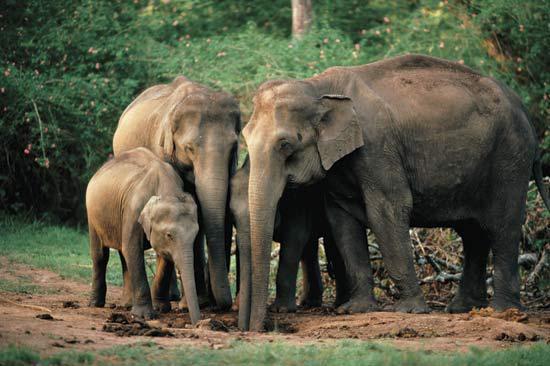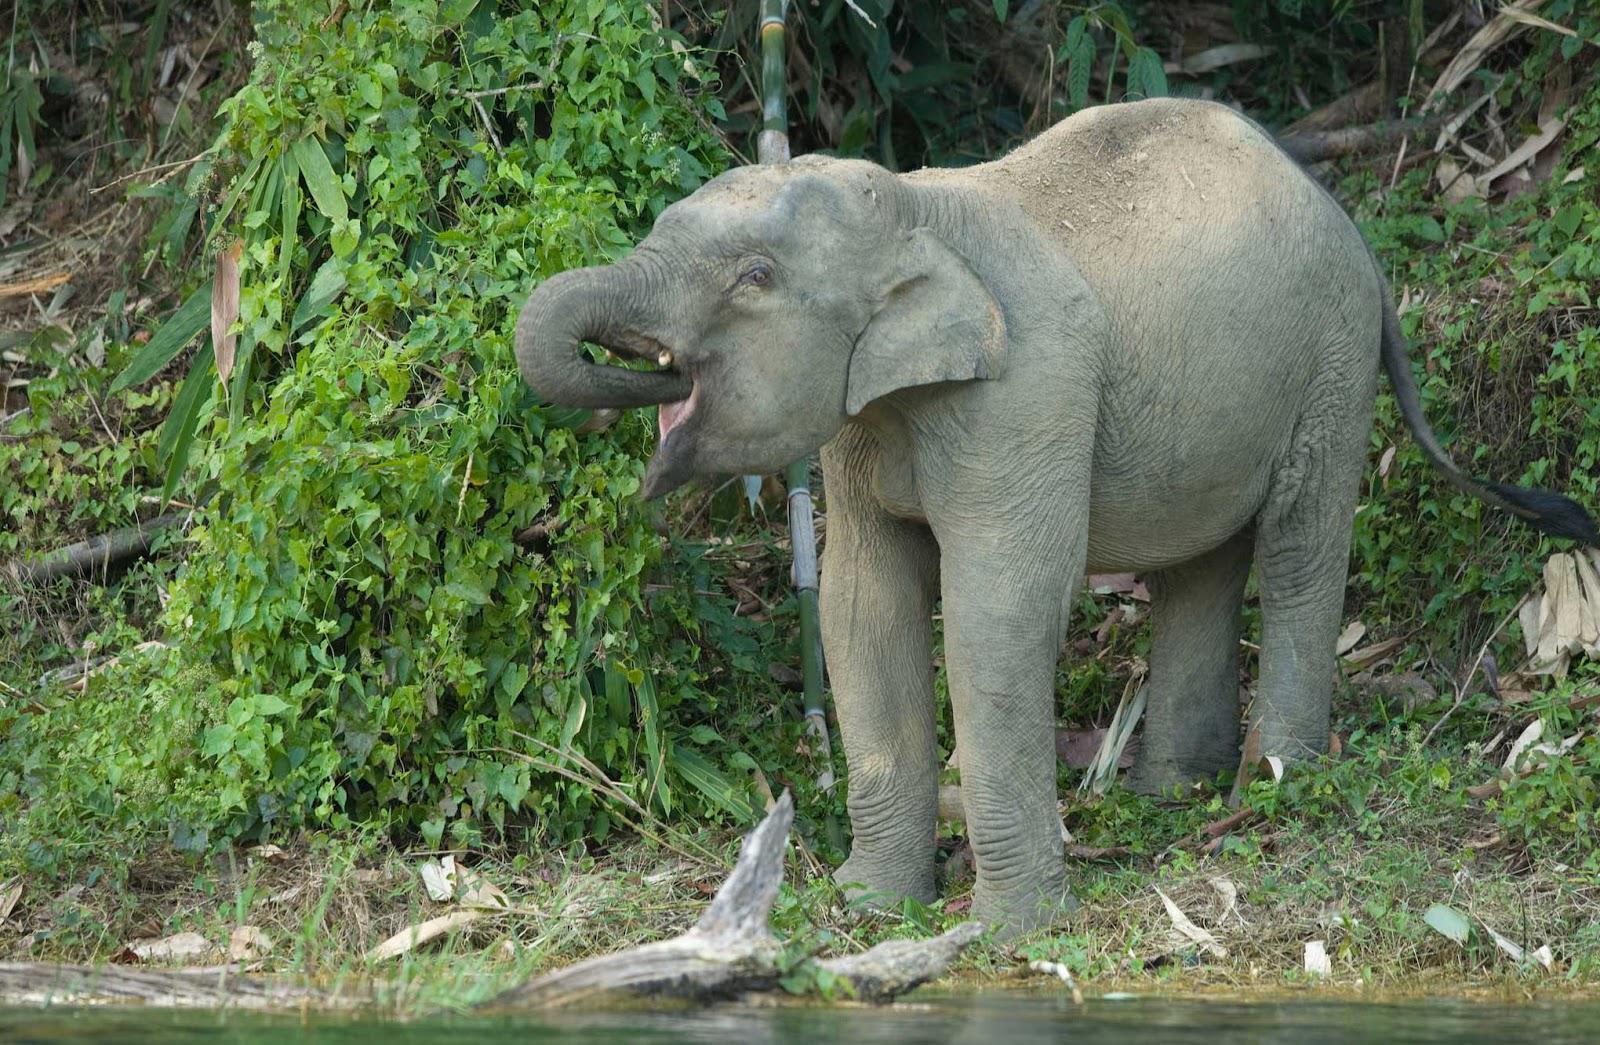The first image is the image on the left, the second image is the image on the right. Analyze the images presented: Is the assertion "There is one animal in the image on the right." valid? Answer yes or no. Yes. 